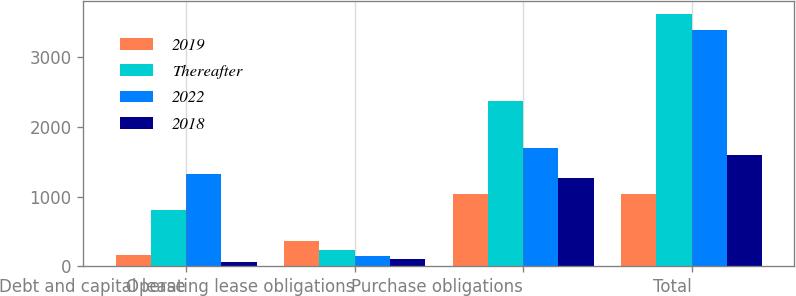Convert chart to OTSL. <chart><loc_0><loc_0><loc_500><loc_500><stacked_bar_chart><ecel><fcel>Debt and capital lease<fcel>Operating lease obligations<fcel>Purchase obligations<fcel>Total<nl><fcel>2019<fcel>161<fcel>359<fcel>1041<fcel>1041<nl><fcel>Thereafter<fcel>811<fcel>236<fcel>2375<fcel>3620<nl><fcel>2022<fcel>1319<fcel>148<fcel>1697<fcel>3383<nl><fcel>2018<fcel>58<fcel>104<fcel>1271<fcel>1592<nl></chart> 